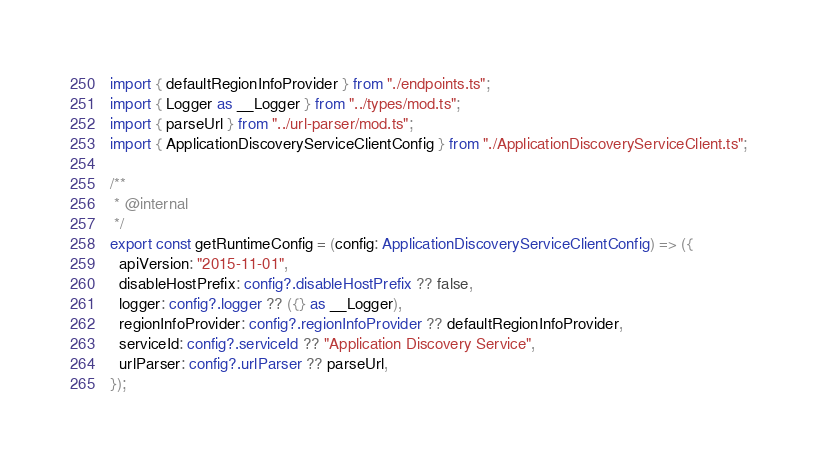<code> <loc_0><loc_0><loc_500><loc_500><_TypeScript_>import { defaultRegionInfoProvider } from "./endpoints.ts";
import { Logger as __Logger } from "../types/mod.ts";
import { parseUrl } from "../url-parser/mod.ts";
import { ApplicationDiscoveryServiceClientConfig } from "./ApplicationDiscoveryServiceClient.ts";

/**
 * @internal
 */
export const getRuntimeConfig = (config: ApplicationDiscoveryServiceClientConfig) => ({
  apiVersion: "2015-11-01",
  disableHostPrefix: config?.disableHostPrefix ?? false,
  logger: config?.logger ?? ({} as __Logger),
  regionInfoProvider: config?.regionInfoProvider ?? defaultRegionInfoProvider,
  serviceId: config?.serviceId ?? "Application Discovery Service",
  urlParser: config?.urlParser ?? parseUrl,
});
</code> 